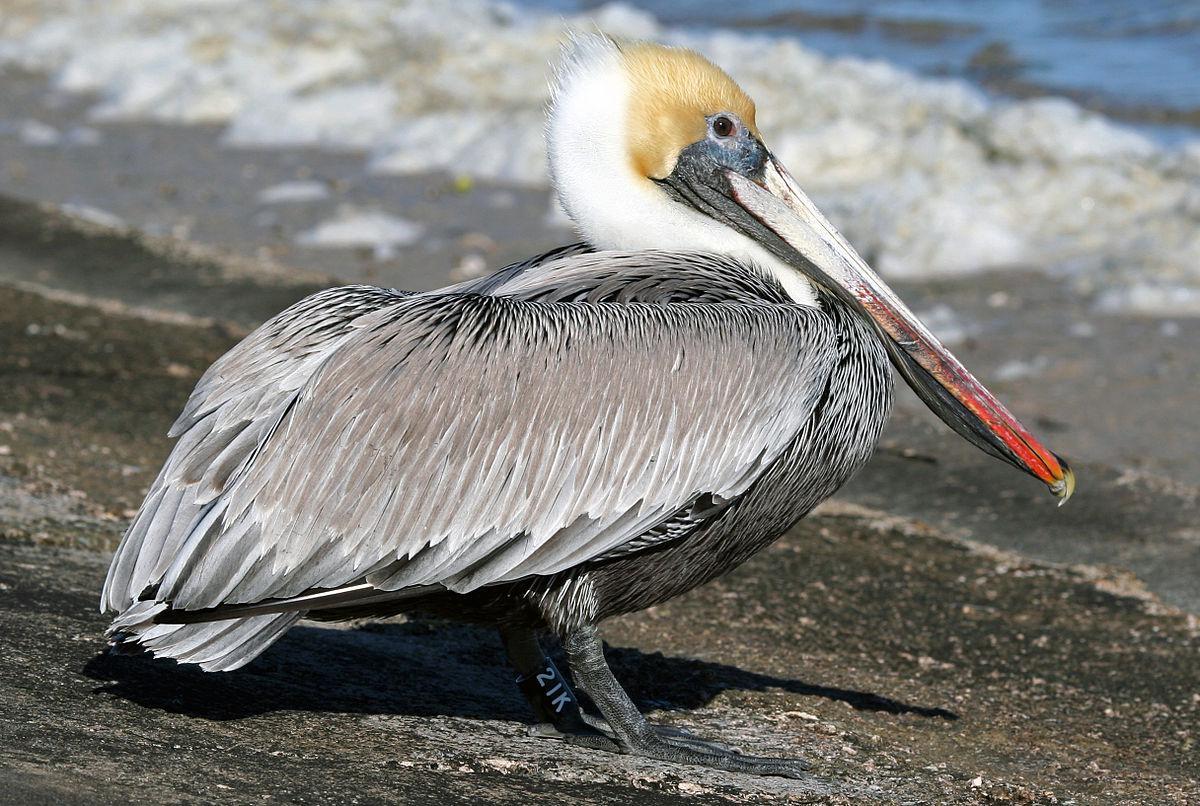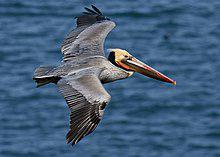The first image is the image on the left, the second image is the image on the right. Considering the images on both sides, is "There is one flying bird." valid? Answer yes or no. Yes. 